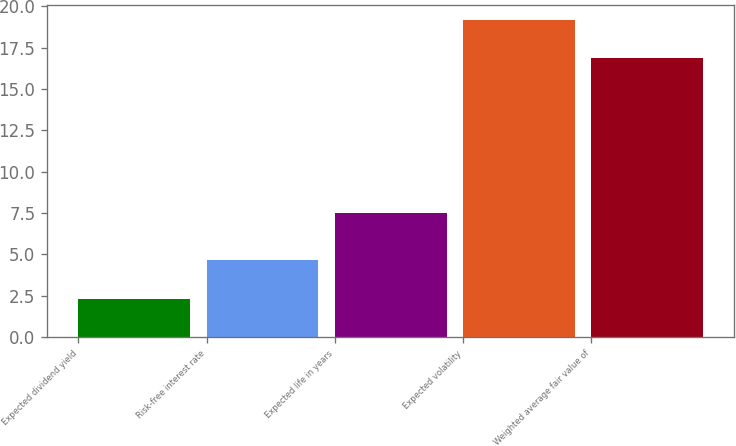<chart> <loc_0><loc_0><loc_500><loc_500><bar_chart><fcel>Expected dividend yield<fcel>Risk-free interest rate<fcel>Expected life in years<fcel>Expected volatility<fcel>Weighted average fair value of<nl><fcel>2.28<fcel>4.65<fcel>7.5<fcel>19.15<fcel>16.85<nl></chart> 